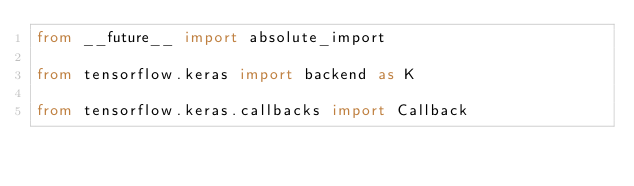Convert code to text. <code><loc_0><loc_0><loc_500><loc_500><_Python_>from __future__ import absolute_import

from tensorflow.keras import backend as K

from tensorflow.keras.callbacks import Callback
</code> 